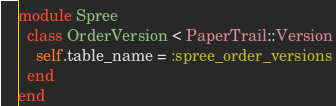<code> <loc_0><loc_0><loc_500><loc_500><_Ruby_>module Spree
  class OrderVersion < PaperTrail::Version
    self.table_name = :spree_order_versions
  end
end </code> 